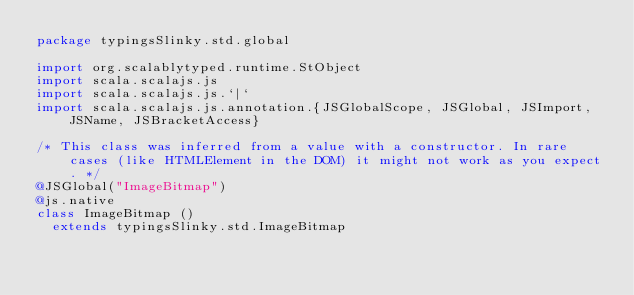Convert code to text. <code><loc_0><loc_0><loc_500><loc_500><_Scala_>package typingsSlinky.std.global

import org.scalablytyped.runtime.StObject
import scala.scalajs.js
import scala.scalajs.js.`|`
import scala.scalajs.js.annotation.{JSGlobalScope, JSGlobal, JSImport, JSName, JSBracketAccess}

/* This class was inferred from a value with a constructor. In rare cases (like HTMLElement in the DOM) it might not work as you expect. */
@JSGlobal("ImageBitmap")
@js.native
class ImageBitmap ()
  extends typingsSlinky.std.ImageBitmap
</code> 